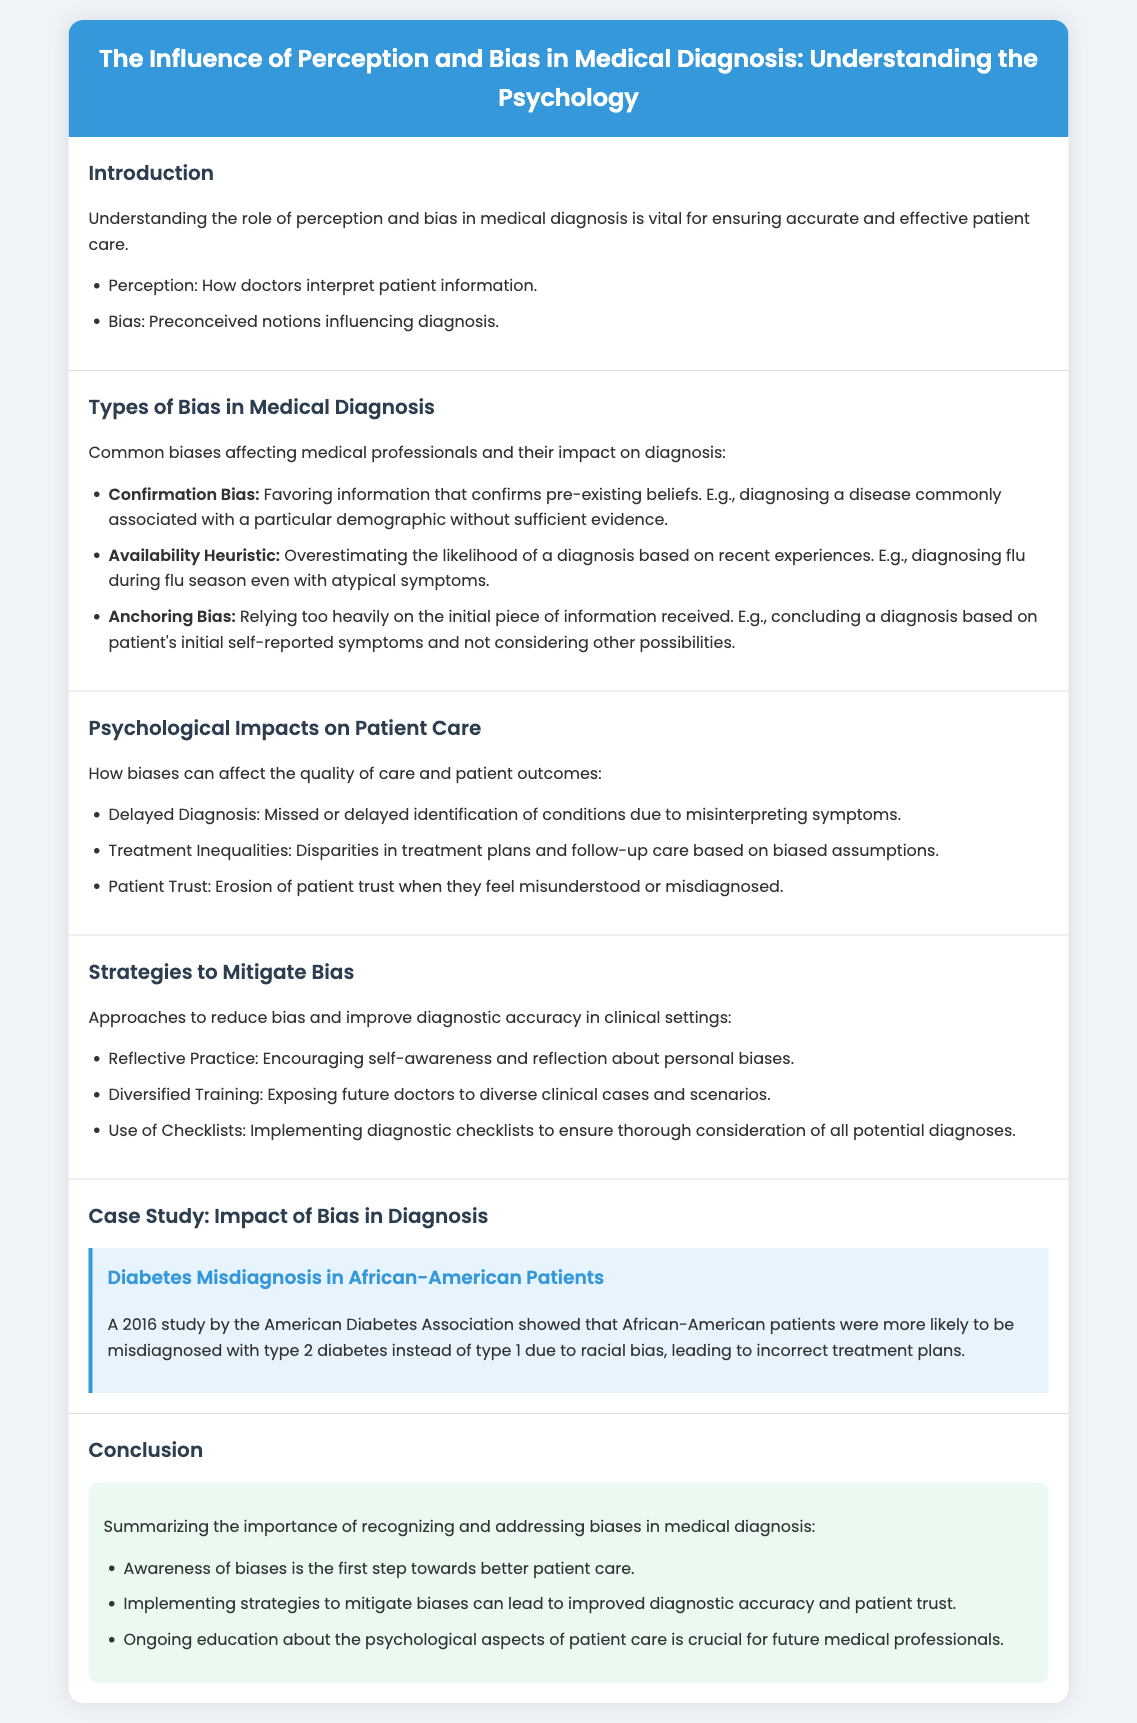What is the title of the presentation? The title is stated in the header of the document.
Answer: The Influence of Perception and Bias in Medical Diagnosis: Understanding the Psychology What are the three types of bias mentioned? The document lists specific types of bias under a separate section.
Answer: Confirmation Bias, Availability Heuristic, Anchoring Bias What psychological impact is associated with misdiagnosis? The impacts listed in the document relate to potential patient care outcomes.
Answer: Delayed Diagnosis Which strategy is suggested to promote self-awareness? The document lists various strategies to mitigate bias, including specific approaches.
Answer: Reflective Practice What case study is highlighted in the presentation? The case study section provides an example relevant to the bias discussed.
Answer: Diabetes Misdiagnosis in African-American Patients What is identified as the first step towards better patient care? This point is made in the conclusion section toward recognizing biases.
Answer: Awareness of biases How can treatment inequalities arise according to the presentation? The document explains specific factors that might contribute to treatment disparities.
Answer: Biased assumptions What organization conducted the diabetes misdiagnosis study? The source of the case study is mentioned within the content.
Answer: American Diabetes Association 